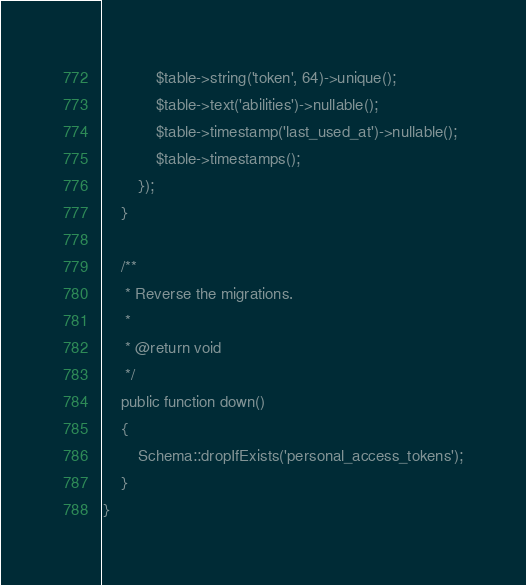Convert code to text. <code><loc_0><loc_0><loc_500><loc_500><_PHP_>            $table->string('token', 64)->unique();
            $table->text('abilities')->nullable();
            $table->timestamp('last_used_at')->nullable();
            $table->timestamps();
        });
    }

    /**
     * Reverse the migrations.
     *
     * @return void
     */
    public function down()
    {
        Schema::dropIfExists('personal_access_tokens');
    }
}
</code> 